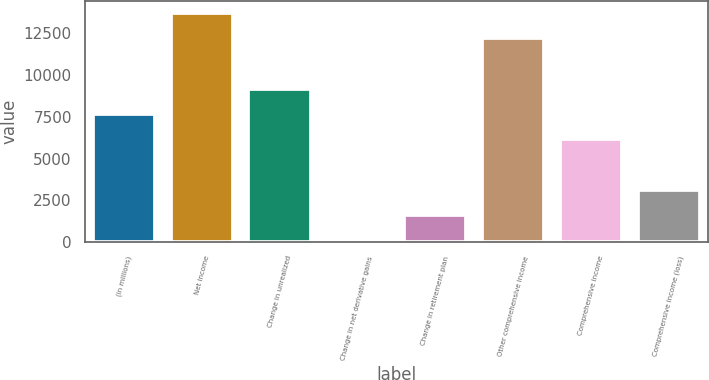Convert chart to OTSL. <chart><loc_0><loc_0><loc_500><loc_500><bar_chart><fcel>(in millions)<fcel>Net income<fcel>Change in unrealized<fcel>Change in net derivative gains<fcel>Change in retirement plan<fcel>Other comprehensive income<fcel>Comprehensive income<fcel>Comprehensive income (loss)<nl><fcel>7671<fcel>13732.6<fcel>9186.4<fcel>94<fcel>1609.4<fcel>12217.2<fcel>6155.6<fcel>3124.8<nl></chart> 